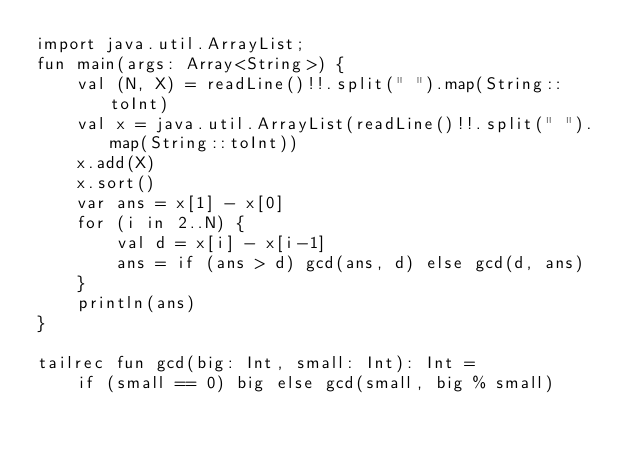<code> <loc_0><loc_0><loc_500><loc_500><_Kotlin_>import java.util.ArrayList;
fun main(args: Array<String>) {
    val (N, X) = readLine()!!.split(" ").map(String::toInt)
    val x = java.util.ArrayList(readLine()!!.split(" ").map(String::toInt))
    x.add(X)
    x.sort()
    var ans = x[1] - x[0]
    for (i in 2..N) {
        val d = x[i] - x[i-1]
        ans = if (ans > d) gcd(ans, d) else gcd(d, ans)
    }
    println(ans)
}

tailrec fun gcd(big: Int, small: Int): Int =
    if (small == 0) big else gcd(small, big % small)</code> 